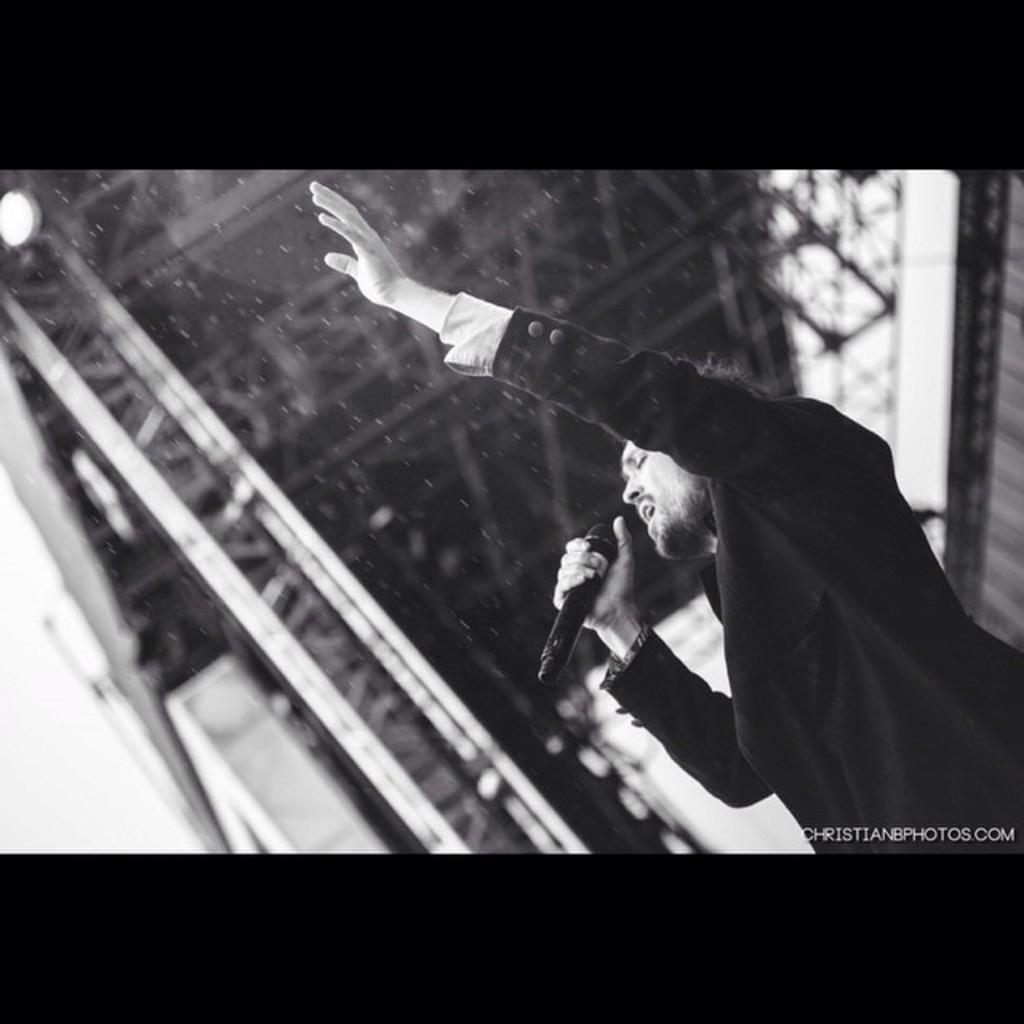What is the person in the image doing? The person is singing. What object is the person holding in the image? The person is holding a mic. Where is the person located in the image? The person is on a rooftop. What can be seen in the image besides the person? There are lights in the image. What is the color of the image's borders? The borders of the image are black in color. Is there any text present in the image? Yes, there is text on the image. What is the person thinking about while singing in the image? The image does not provide information about the person's thoughts, so we cannot determine what they are thinking about while singing. 